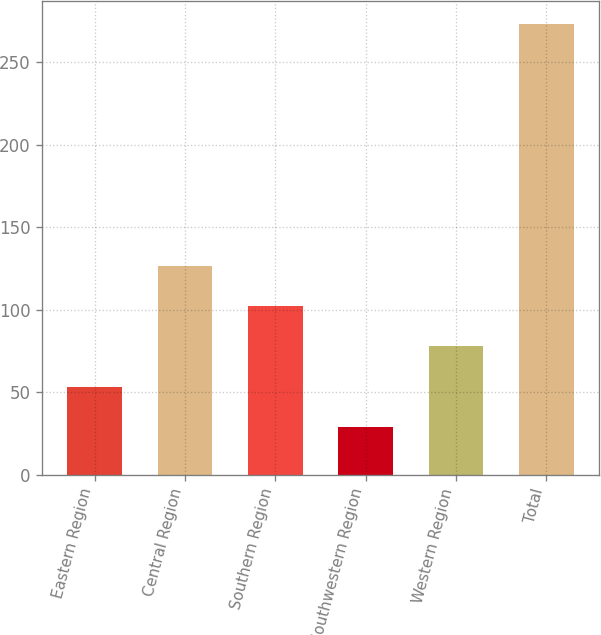<chart> <loc_0><loc_0><loc_500><loc_500><bar_chart><fcel>Eastern Region<fcel>Central Region<fcel>Southern Region<fcel>Southwestern Region<fcel>Western Region<fcel>Total<nl><fcel>53.33<fcel>126.62<fcel>102.19<fcel>28.9<fcel>77.76<fcel>273.2<nl></chart> 